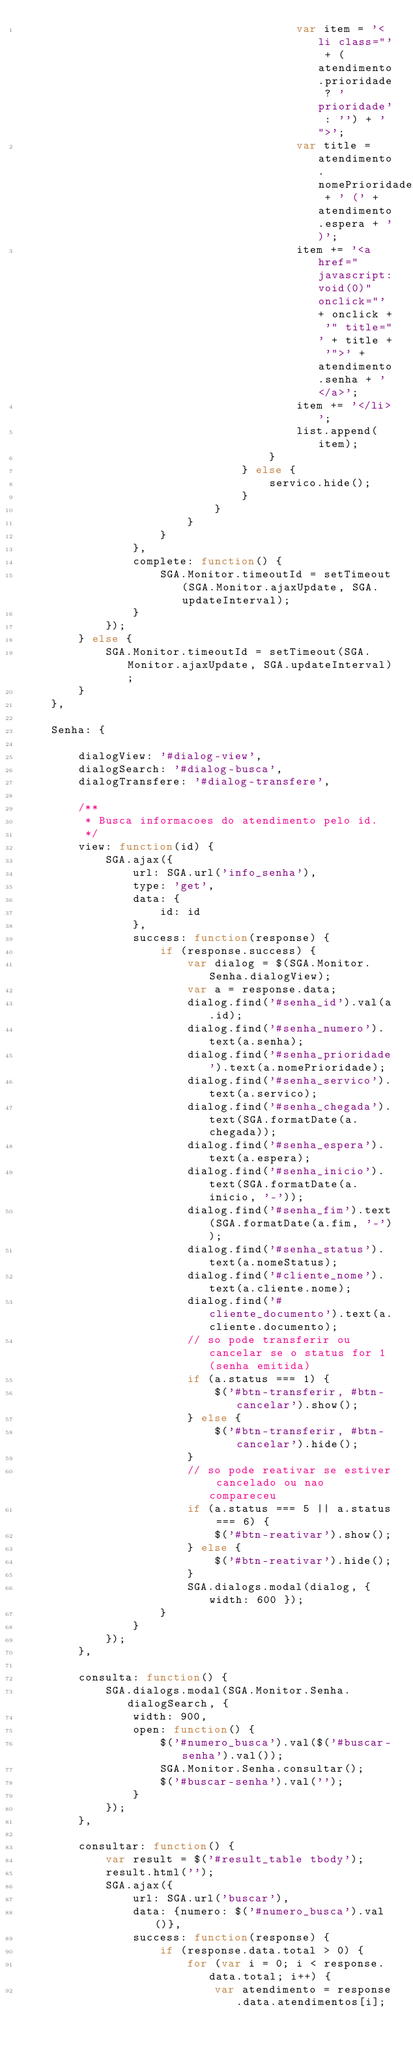Convert code to text. <code><loc_0><loc_0><loc_500><loc_500><_JavaScript_>                                        var item = '<li class="' + (atendimento.prioridade ? 'prioridade' : '') + '">';
                                        var title = atendimento.nomePrioridade + ' (' + atendimento.espera + ')';
                                        item += '<a href="javascript:void(0)" onclick="' + onclick + '" title="' + title + '">' + atendimento.senha + '</a>';
                                        item += '</li>';
                                        list.append(item);
                                    }
                                } else {
                                    servico.hide();
                                }
                            }
                        }
                    }
                },
                complete: function() {
                    SGA.Monitor.timeoutId = setTimeout(SGA.Monitor.ajaxUpdate, SGA.updateInterval);
                }
            });
        } else {
            SGA.Monitor.timeoutId = setTimeout(SGA.Monitor.ajaxUpdate, SGA.updateInterval);
        }
    },
    
    Senha: {
        
        dialogView: '#dialog-view',
        dialogSearch: '#dialog-busca',
        dialogTransfere: '#dialog-transfere',
    
        /**
         * Busca informacoes do atendimento pelo id.
         */
        view: function(id) {
            SGA.ajax({
                url: SGA.url('info_senha'),
                type: 'get',
                data: {
                    id: id
                },
                success: function(response) {
                    if (response.success) {
                        var dialog = $(SGA.Monitor.Senha.dialogView);
                        var a = response.data;
                        dialog.find('#senha_id').val(a.id);
                        dialog.find('#senha_numero').text(a.senha);
                        dialog.find('#senha_prioridade').text(a.nomePrioridade);
                        dialog.find('#senha_servico').text(a.servico);
                        dialog.find('#senha_chegada').text(SGA.formatDate(a.chegada));
                        dialog.find('#senha_espera').text(a.espera);
                        dialog.find('#senha_inicio').text(SGA.formatDate(a.inicio, '-'));
                        dialog.find('#senha_fim').text(SGA.formatDate(a.fim, '-'));
                        dialog.find('#senha_status').text(a.nomeStatus);
                        dialog.find('#cliente_nome').text(a.cliente.nome);
                        dialog.find('#cliente_documento').text(a.cliente.documento);
                        // so pode transferir ou cancelar se o status for 1 (senha emitida)
                        if (a.status === 1) {
                            $('#btn-transferir, #btn-cancelar').show();
                        } else {
                            $('#btn-transferir, #btn-cancelar').hide();
                        }
                        // so pode reativar se estiver cancelado ou nao compareceu
                        if (a.status === 5 || a.status === 6) {
                            $('#btn-reativar').show();
                        } else {
                            $('#btn-reativar').hide();
                        }
                        SGA.dialogs.modal(dialog, { width: 600 });
                    }
                }
            });
        },
        
        consulta: function() {
            SGA.dialogs.modal(SGA.Monitor.Senha.dialogSearch, { 
                width: 900,
                open: function() {
                    $('#numero_busca').val($('#buscar-senha').val());
                    SGA.Monitor.Senha.consultar();
                    $('#buscar-senha').val('');
                }
            });
        },
        
        consultar: function() {
            var result = $('#result_table tbody');
            result.html('');
            SGA.ajax({
                url: SGA.url('buscar'),
                data: {numero: $('#numero_busca').val()},
                success: function(response) {
                    if (response.data.total > 0) {
                        for (var i = 0; i < response.data.total; i++) {
                            var atendimento = response.data.atendimentos[i];</code> 